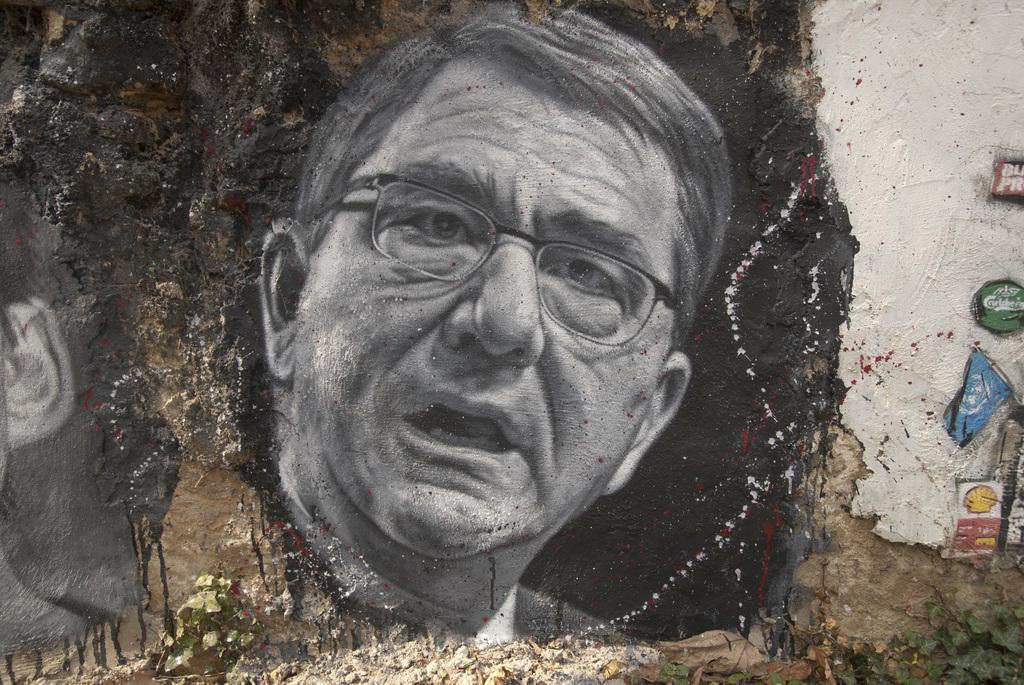What is the main subject of the image? The main subject of the image is a picture of a man. What can be said about the color of the picture of the man? The picture of the man is black and white in color. What other object is visible in the image? There is a flag in the image. Can you describe any other elements in the image? There are other unspecified things in the image. What type of writing can be seen on the man's shirt in the image? There is no writing visible on the man's shirt in the image, as it is a black and white picture. How many dolls are present in the image? There are no dolls present in the image. 